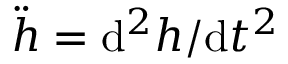Convert formula to latex. <formula><loc_0><loc_0><loc_500><loc_500>\ddot { h } = { d ^ { 2 } h } / { d t ^ { 2 } }</formula> 